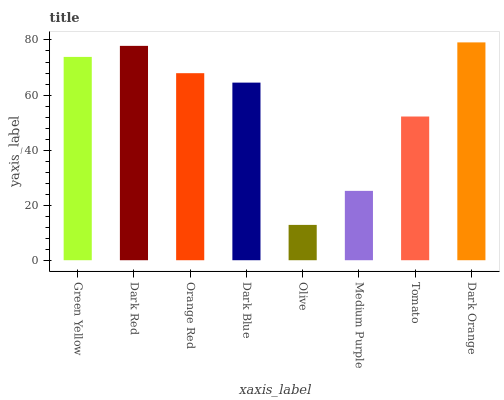Is Olive the minimum?
Answer yes or no. Yes. Is Dark Orange the maximum?
Answer yes or no. Yes. Is Dark Red the minimum?
Answer yes or no. No. Is Dark Red the maximum?
Answer yes or no. No. Is Dark Red greater than Green Yellow?
Answer yes or no. Yes. Is Green Yellow less than Dark Red?
Answer yes or no. Yes. Is Green Yellow greater than Dark Red?
Answer yes or no. No. Is Dark Red less than Green Yellow?
Answer yes or no. No. Is Orange Red the high median?
Answer yes or no. Yes. Is Dark Blue the low median?
Answer yes or no. Yes. Is Olive the high median?
Answer yes or no. No. Is Tomato the low median?
Answer yes or no. No. 